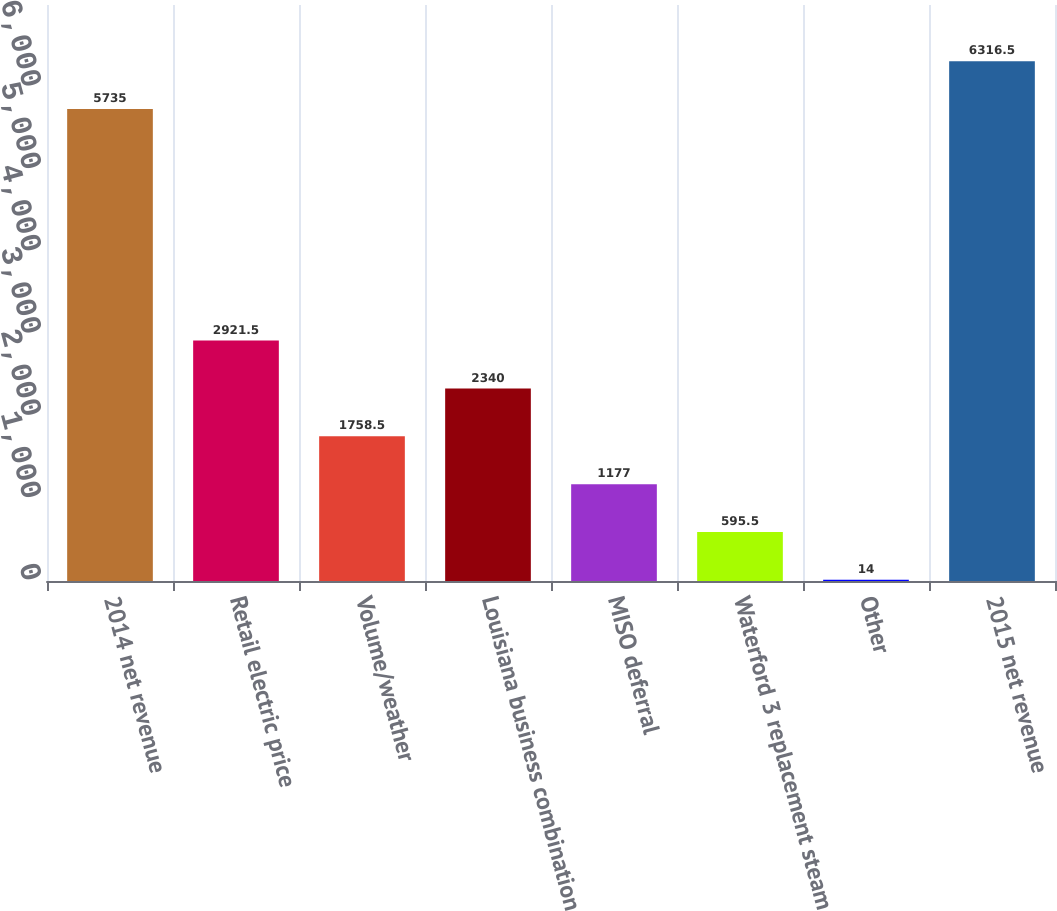<chart> <loc_0><loc_0><loc_500><loc_500><bar_chart><fcel>2014 net revenue<fcel>Retail electric price<fcel>Volume/weather<fcel>Louisiana business combination<fcel>MISO deferral<fcel>Waterford 3 replacement steam<fcel>Other<fcel>2015 net revenue<nl><fcel>5735<fcel>2921.5<fcel>1758.5<fcel>2340<fcel>1177<fcel>595.5<fcel>14<fcel>6316.5<nl></chart> 